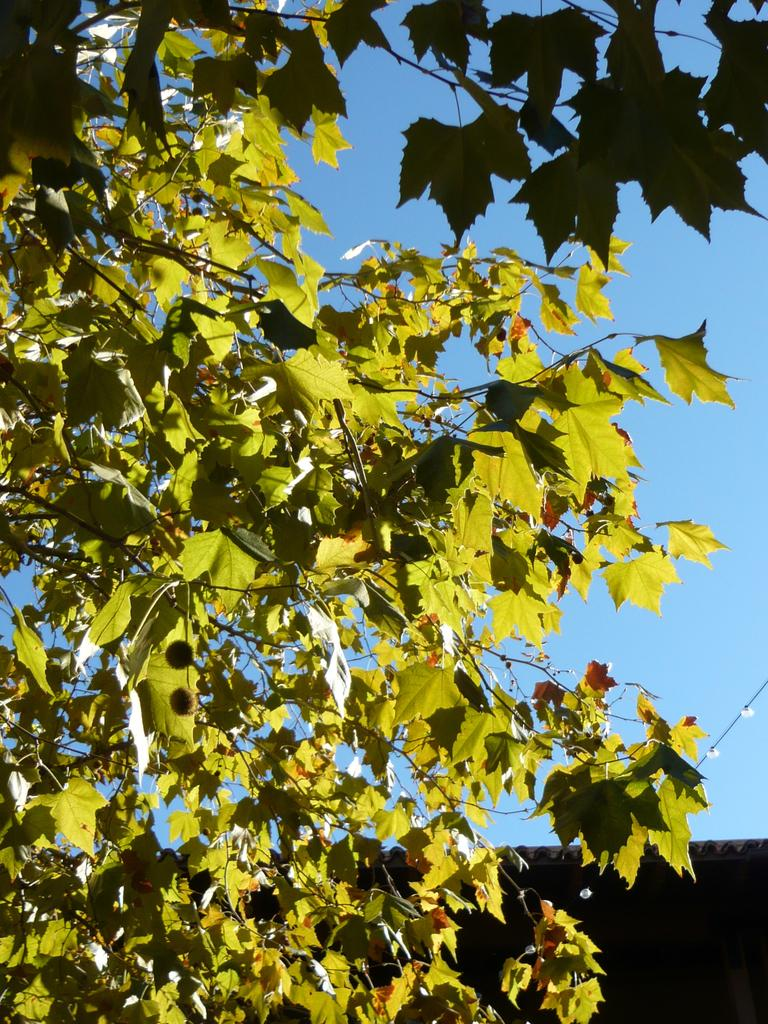What type of vegetation is present in the image? There are green leaves in the image. What color is the sky in the image? The sky is blue in the image. What type of seed is planted in the shape of an idea in the image? There is no seed or idea present in the image; it only features green leaves and a blue sky. 